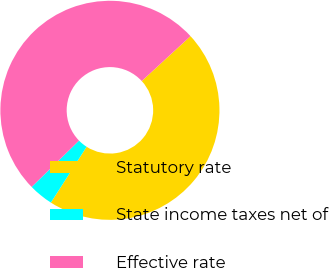Convert chart. <chart><loc_0><loc_0><loc_500><loc_500><pie_chart><fcel>Statutory rate<fcel>State income taxes net of<fcel>Effective rate<nl><fcel>45.9%<fcel>3.61%<fcel>50.49%<nl></chart> 